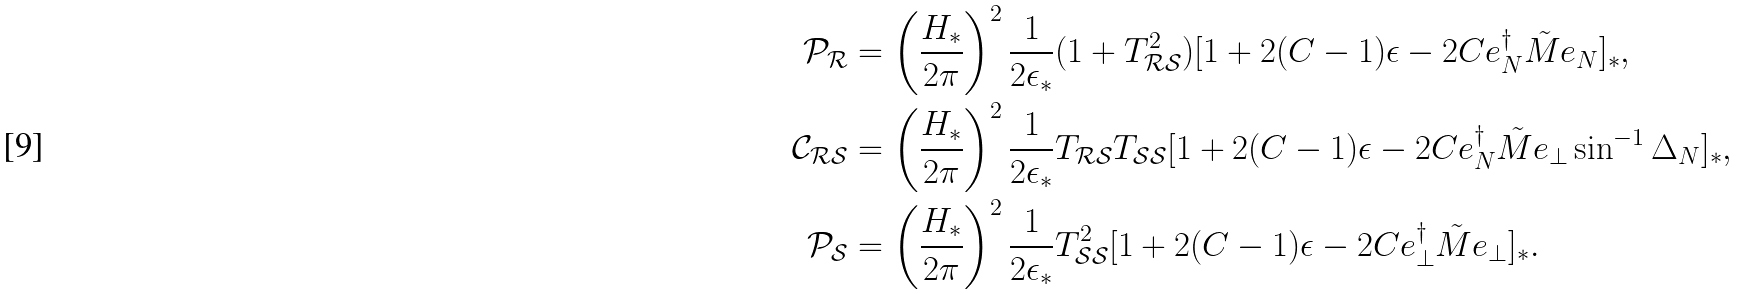Convert formula to latex. <formula><loc_0><loc_0><loc_500><loc_500>\mathcal { P } _ { \mathcal { R } } & = \left ( \frac { H _ { * } } { 2 \pi } \right ) ^ { 2 } \frac { 1 } { 2 \epsilon _ { * } } ( 1 + T _ { \mathcal { R S } } ^ { 2 } ) [ 1 + 2 ( C - 1 ) \epsilon - 2 C e _ { N } ^ { \dag } \tilde { M } e _ { N } ] _ { * } , \\ \mathcal { C } _ { \mathcal { R S } } & = \left ( \frac { H _ { * } } { 2 \pi } \right ) ^ { 2 } \frac { 1 } { 2 \epsilon _ { * } } T _ { \mathcal { R S } } T _ { \mathcal { S S } } [ 1 + 2 ( C - 1 ) \epsilon - 2 C e _ { N } ^ { \dag } \tilde { M } e _ { \perp } \sin ^ { - 1 } \Delta _ { N } ] _ { * } , \\ \mathcal { P } _ { \mathcal { S } } & = \left ( \frac { H _ { * } } { 2 \pi } \right ) ^ { 2 } \frac { 1 } { 2 \epsilon _ { * } } T _ { \mathcal { S S } } ^ { 2 } [ 1 + 2 ( C - 1 ) \epsilon - 2 C e _ { \perp } ^ { \dag } \tilde { M } e _ { \perp } ] _ { * } .</formula> 